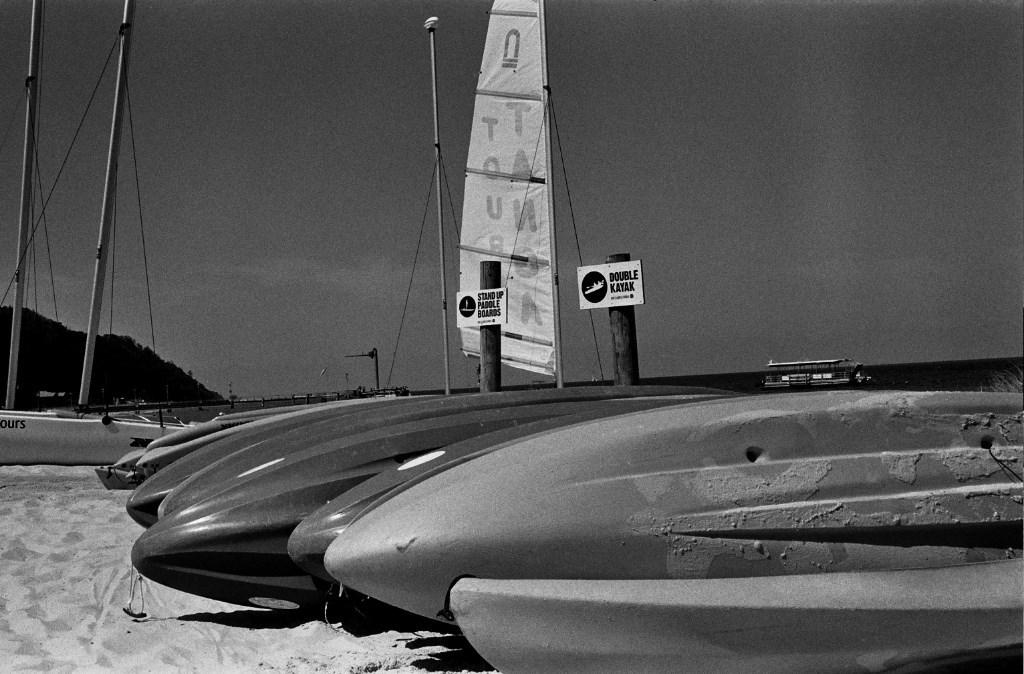What type of vehicles can be seen in the image? There are boats and a ship in the image. What type of terrain is visible in the image? There is sand and hills visible in the image. What natural element is present in the image? There is water in the image. What man-made structures can be seen in the image? Information boards, poles, and ropes are present in the image. How many quinces are hanging from the poles in the image? There are no quinces present in the image. Can you tell me how the eye is used to navigate the ship in the image? There is no mention of an eye or its use for navigation in the image. 